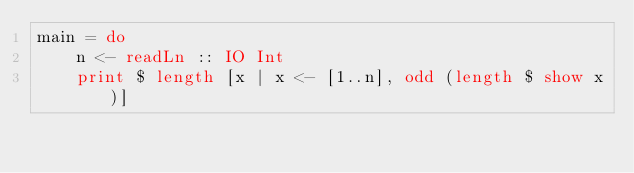<code> <loc_0><loc_0><loc_500><loc_500><_Haskell_>main = do
    n <- readLn :: IO Int
    print $ length [x | x <- [1..n], odd (length $ show x)]
</code> 